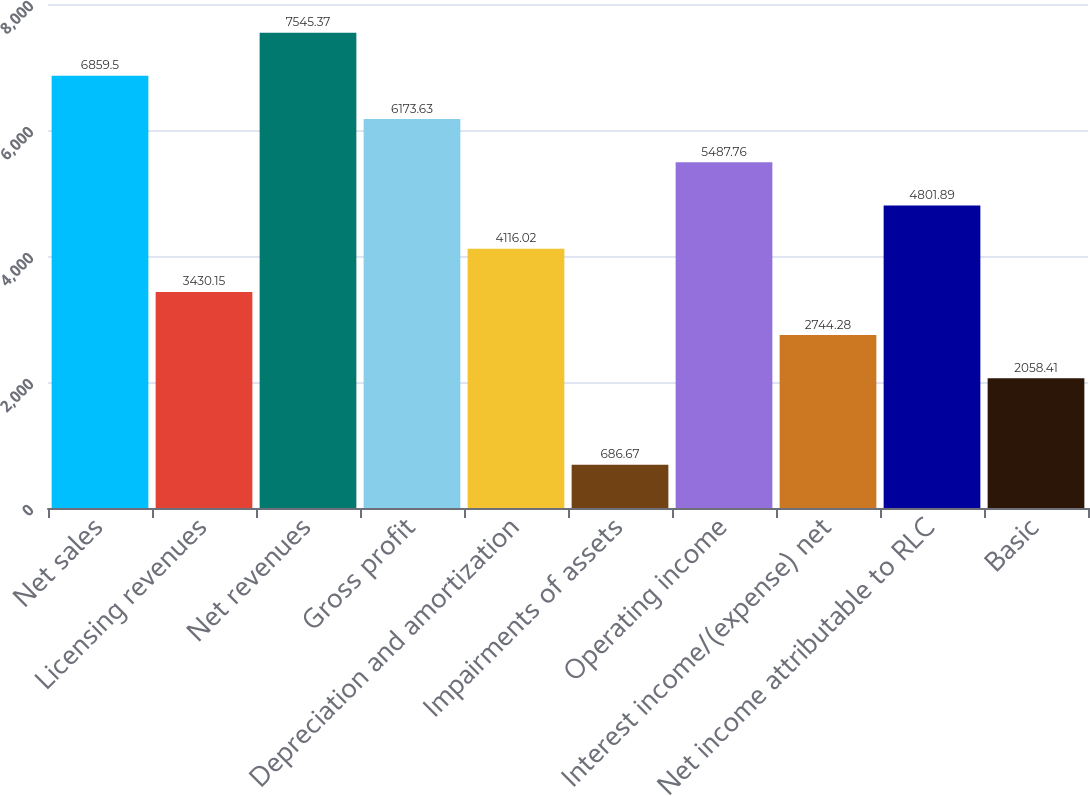Convert chart to OTSL. <chart><loc_0><loc_0><loc_500><loc_500><bar_chart><fcel>Net sales<fcel>Licensing revenues<fcel>Net revenues<fcel>Gross profit<fcel>Depreciation and amortization<fcel>Impairments of assets<fcel>Operating income<fcel>Interest income/(expense) net<fcel>Net income attributable to RLC<fcel>Basic<nl><fcel>6859.5<fcel>3430.15<fcel>7545.37<fcel>6173.63<fcel>4116.02<fcel>686.67<fcel>5487.76<fcel>2744.28<fcel>4801.89<fcel>2058.41<nl></chart> 